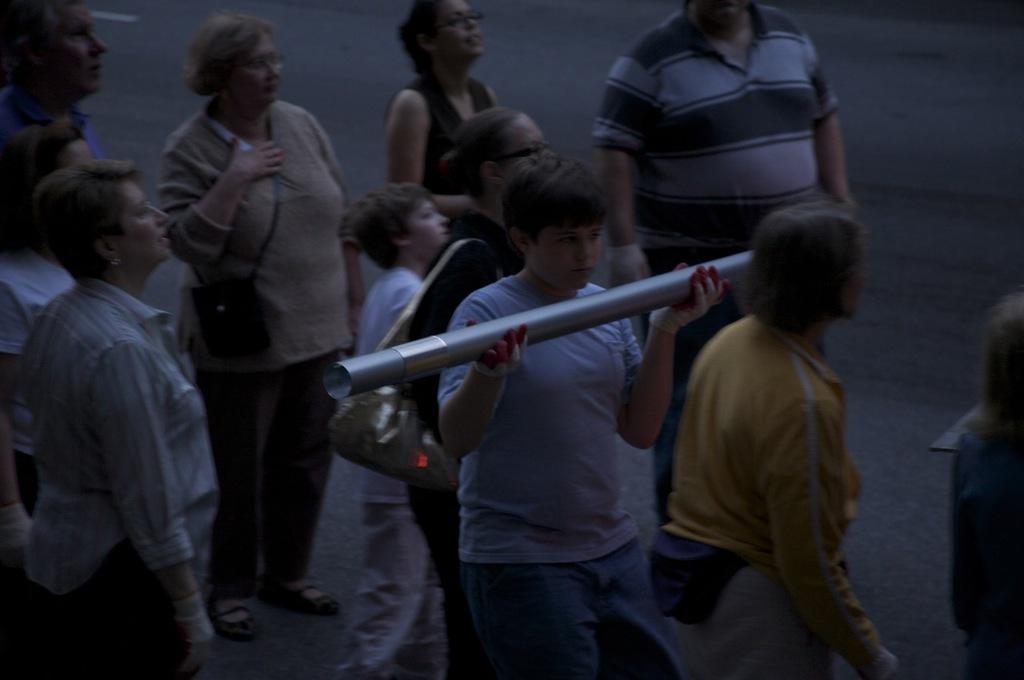How would you summarize this image in a sentence or two? This picture describes about group of people, few people wore bags, in the middle of the image we can see a man he is holding a pipe. 